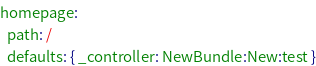<code> <loc_0><loc_0><loc_500><loc_500><_YAML_>homepage:
  path: /
  defaults: { _controller: NewBundle:New:test }

</code> 